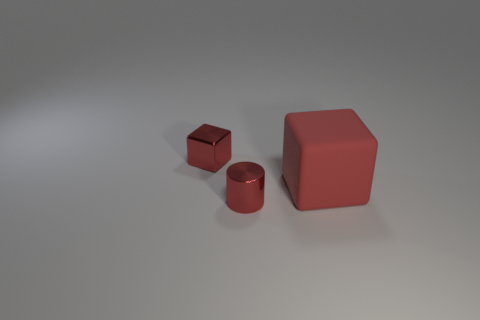Add 3 small red shiny cylinders. How many objects exist? 6 Subtract all cylinders. How many objects are left? 2 Subtract 0 yellow cylinders. How many objects are left? 3 Subtract all small green shiny cylinders. Subtract all matte blocks. How many objects are left? 2 Add 3 tiny things. How many tiny things are left? 5 Add 1 big red matte objects. How many big red matte objects exist? 2 